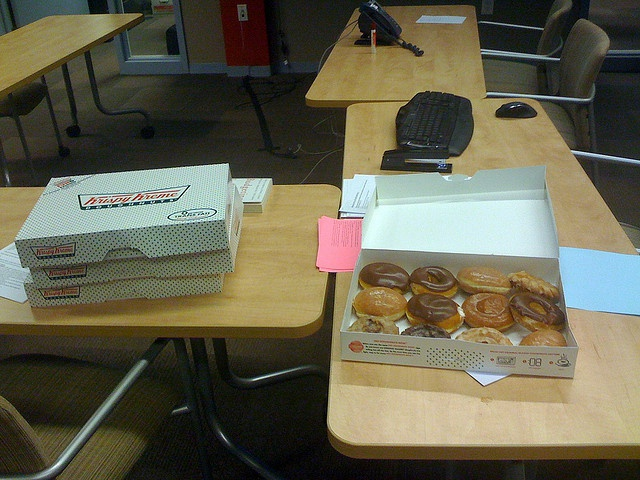Describe the objects in this image and their specific colors. I can see dining table in black, tan, darkgray, and lightblue tones, dining table in black, tan, and olive tones, chair in black, darkgreen, gray, and darkgray tones, dining table in black and olive tones, and chair in black, gray, and darkgreen tones in this image. 